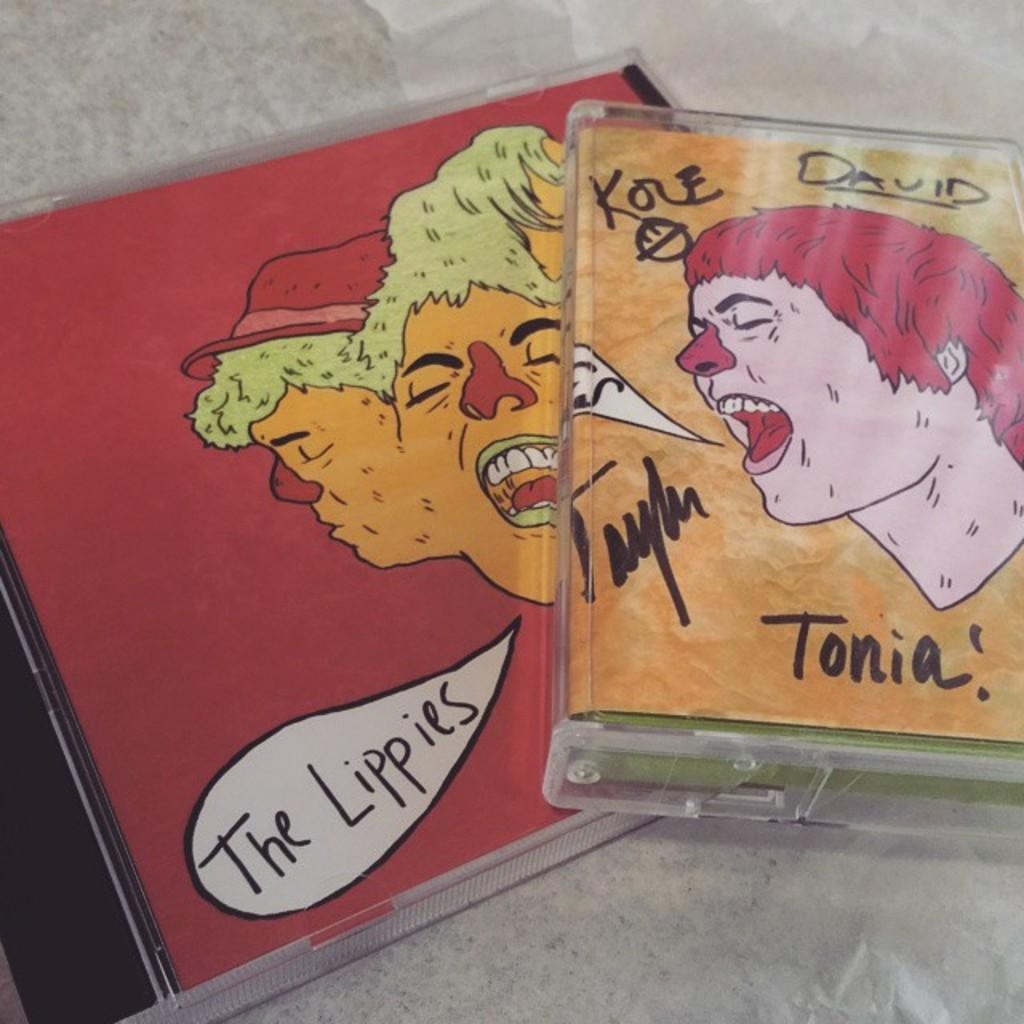What objects are present in the image? There are two cassettes in the image. Where are the cassettes located? The cassettes are on a platform. What type of goat can be seen wearing a coat in the image? There is no goat or coat present in the image; it only features two cassettes on a platform. What branch is the cassette hanging from in the image? There is no branch in the image, and the cassettes are on a platform, not hanging from anything. 